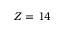<formula> <loc_0><loc_0><loc_500><loc_500>Z = 1 4</formula> 